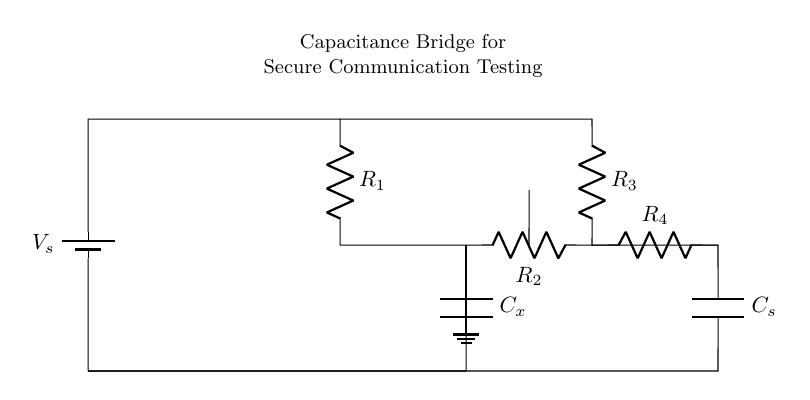What is the power supply voltage in the circuit? The power supply voltage is labeled $V_s$ and is typically represented as a single value. Since it is a generic representation, a specific numeric value is not shown here, but it's assumed to be a standard value like 5V or 12V based on the context of the application.
Answer: Vs What are the types of components used in the circuit? The components in the circuit include resistors, capacitors, a battery, and a detector. The resistors are shown as R1, R2, R3, R4 while the capacitors are depicted as Cx and Cs. The battery provides the power supply for the circuit.
Answer: Resistors, capacitors, battery, detector How many resistors are present in this circuit? The circuit diagram includes a total of four resistors (R1, R2, R3, R4). This can be counted directly from the diagram; each resistor is distinctly labeled.
Answer: Four What role does the capacitor Cx play in this circuit? Capacitor Cx represents the unknown capacitance in the bridge circuit, which is compared against the known capacitor Cs. The capacitance bridge operates by balancing the two capacitors' charge, allowing for accurate measurements.
Answer: Unknown capacitance What is the purpose of the detector in this circuit? The detector's role is to sense the balance condition in the bridge circuit. When the bridge is balanced, the voltage across the detector will be zero, providing a method for determining if Cx matches Cs.
Answer: Sensing balance condition How is the capacitor Cs connected in relation to the power supply? Capacitor Cs is connected in parallel with the resistor R3 and is connected to the same ground as the rest of the circuit components, ensuring it is a part of the bridge measurement setup.
Answer: In parallel 